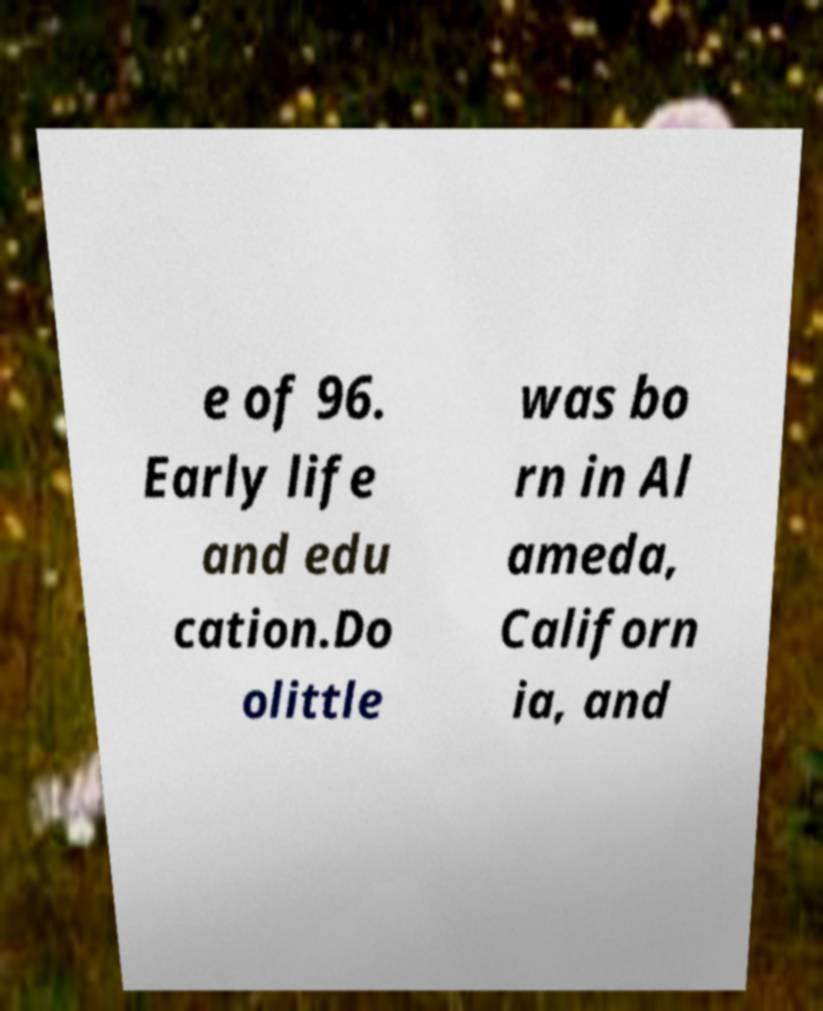Could you extract and type out the text from this image? e of 96. Early life and edu cation.Do olittle was bo rn in Al ameda, Californ ia, and 